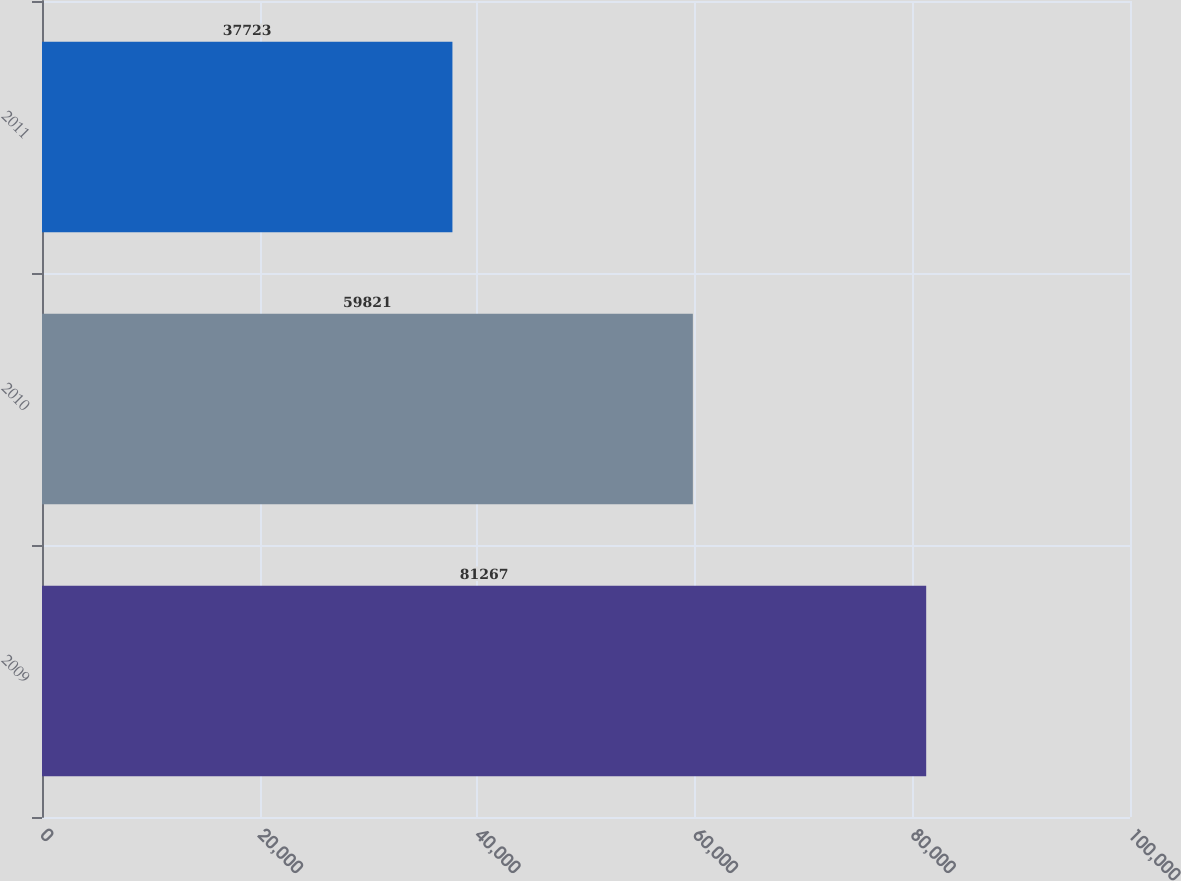<chart> <loc_0><loc_0><loc_500><loc_500><bar_chart><fcel>2009<fcel>2010<fcel>2011<nl><fcel>81267<fcel>59821<fcel>37723<nl></chart> 